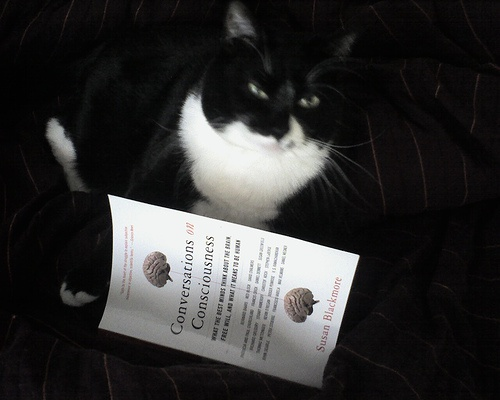Describe the objects in this image and their specific colors. I can see cat in black, lightgray, gray, and darkgray tones and book in black, white, darkgray, and gray tones in this image. 